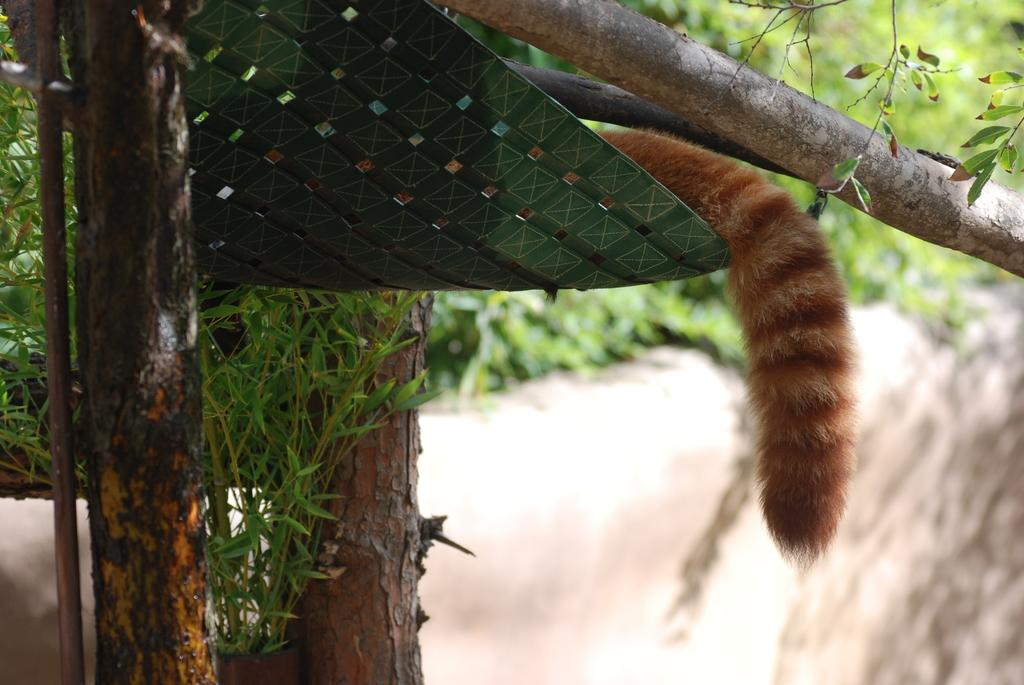What object is on the seat in the image? There is a tail on the seat in the image. What can be seen on the left side of the image? There are trees and leaves on the left side of the image. What is visible in the background of the image? Trees and plants can be seen in the background of the image. What type of shoes is the person wearing in the image? There is no person present in the image, so we cannot determine the type of shoes they might be wearing. 